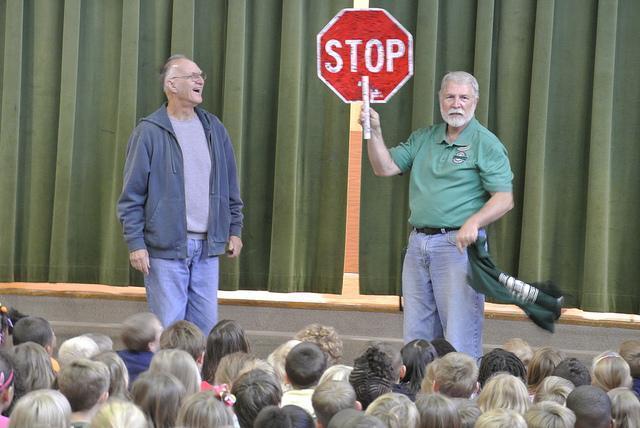How many people are in the photo?
Give a very brief answer. 4. How many bears are there in the picture?
Give a very brief answer. 0. 